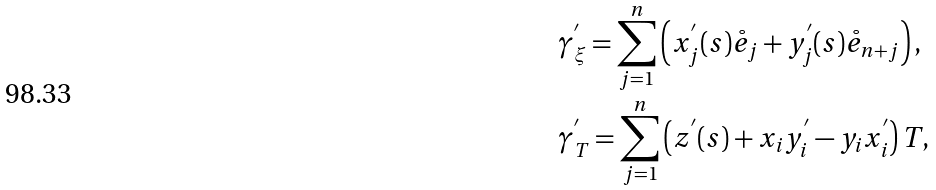Convert formula to latex. <formula><loc_0><loc_0><loc_500><loc_500>& \gamma ^ { ^ { \prime } } _ { \xi } = \sum _ { j = 1 } ^ { n } \left ( x _ { j } ^ { ^ { \prime } } ( s ) \mathring { e } _ { j } + y _ { j } ^ { ^ { \prime } } ( s ) \mathring { e } _ { n + j } \right ) , \\ & \gamma ^ { ^ { \prime } } _ { T } = \sum _ { j = 1 } ^ { n } \left ( z ^ { ^ { \prime } } ( s ) + x _ { i } y _ { i } ^ { ^ { \prime } } - y _ { i } x _ { i } ^ { ^ { \prime } } \right ) T ,</formula> 